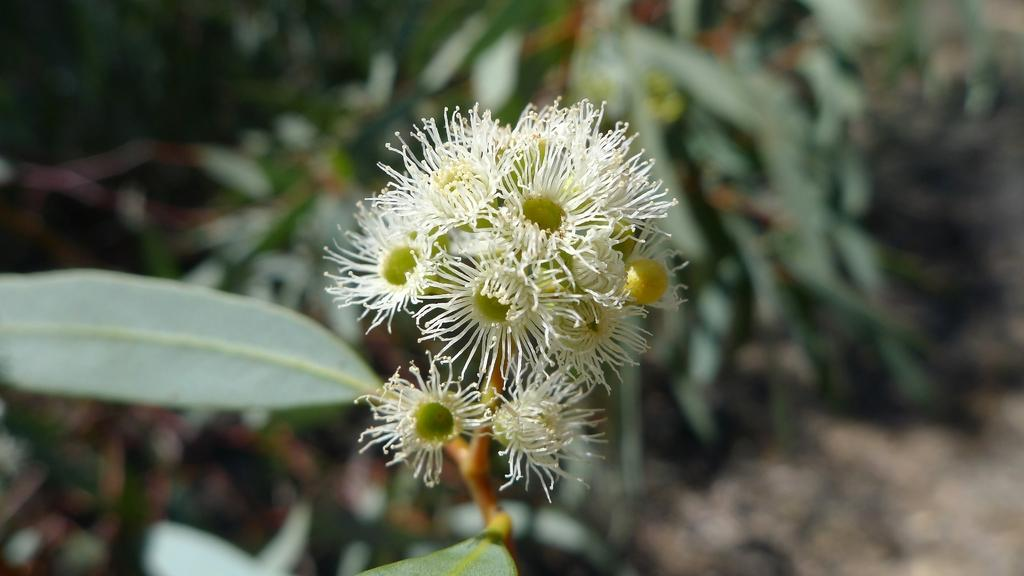What type of plants can be seen in the image? There are flowers and leaves in the image. Can you describe the appearance of the flowers? Unfortunately, the specific appearance of the flowers cannot be determined from the provided facts. Are there any other elements present in the image besides the flowers and leaves? No additional elements are mentioned in the provided facts. What type of jelly is being used to fuel the sidewalk in the image? There is no jelly, fuel, or sidewalk present in the image. 